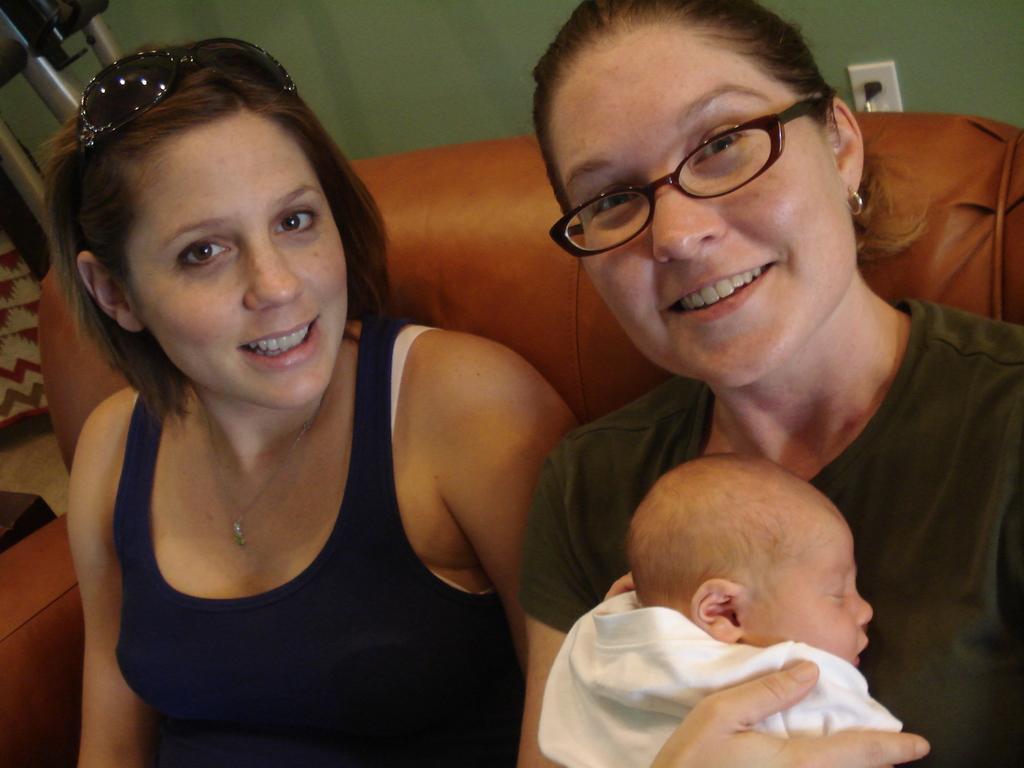Please provide a concise description of this image. In this image there are two people sitting, and one woman is wearing spectacles and holding a baby and there is a couch. In the background there is an object and wall, and there is a switch board. 